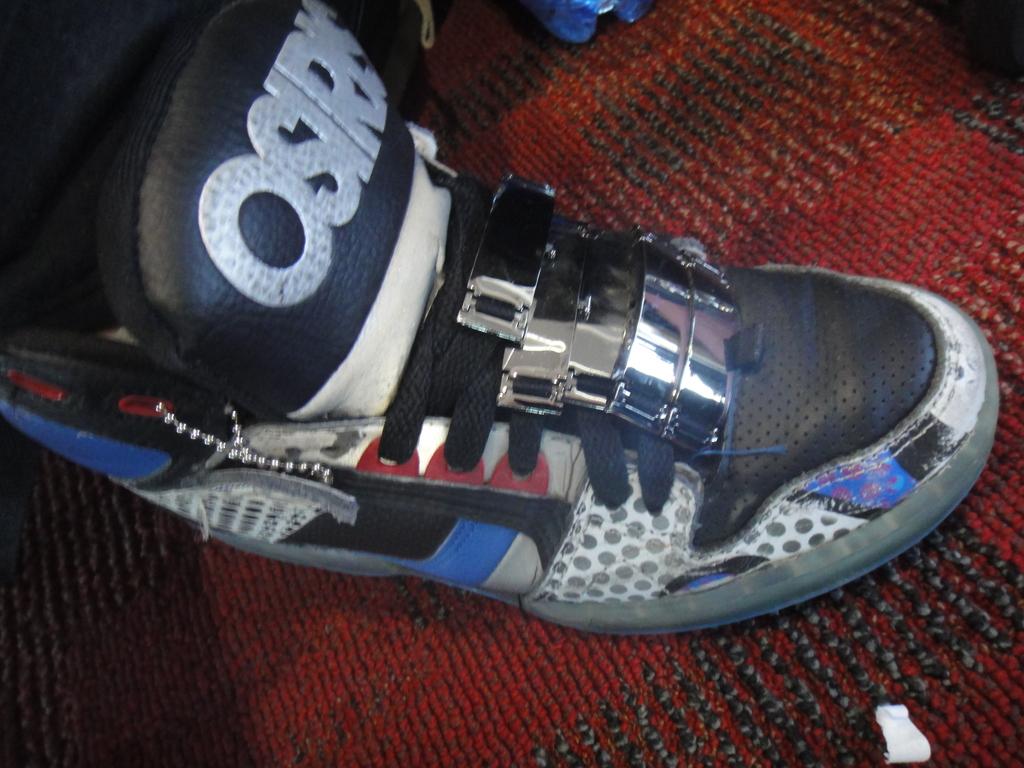This shoes is from which label?
Make the answer very short. Osiris. 